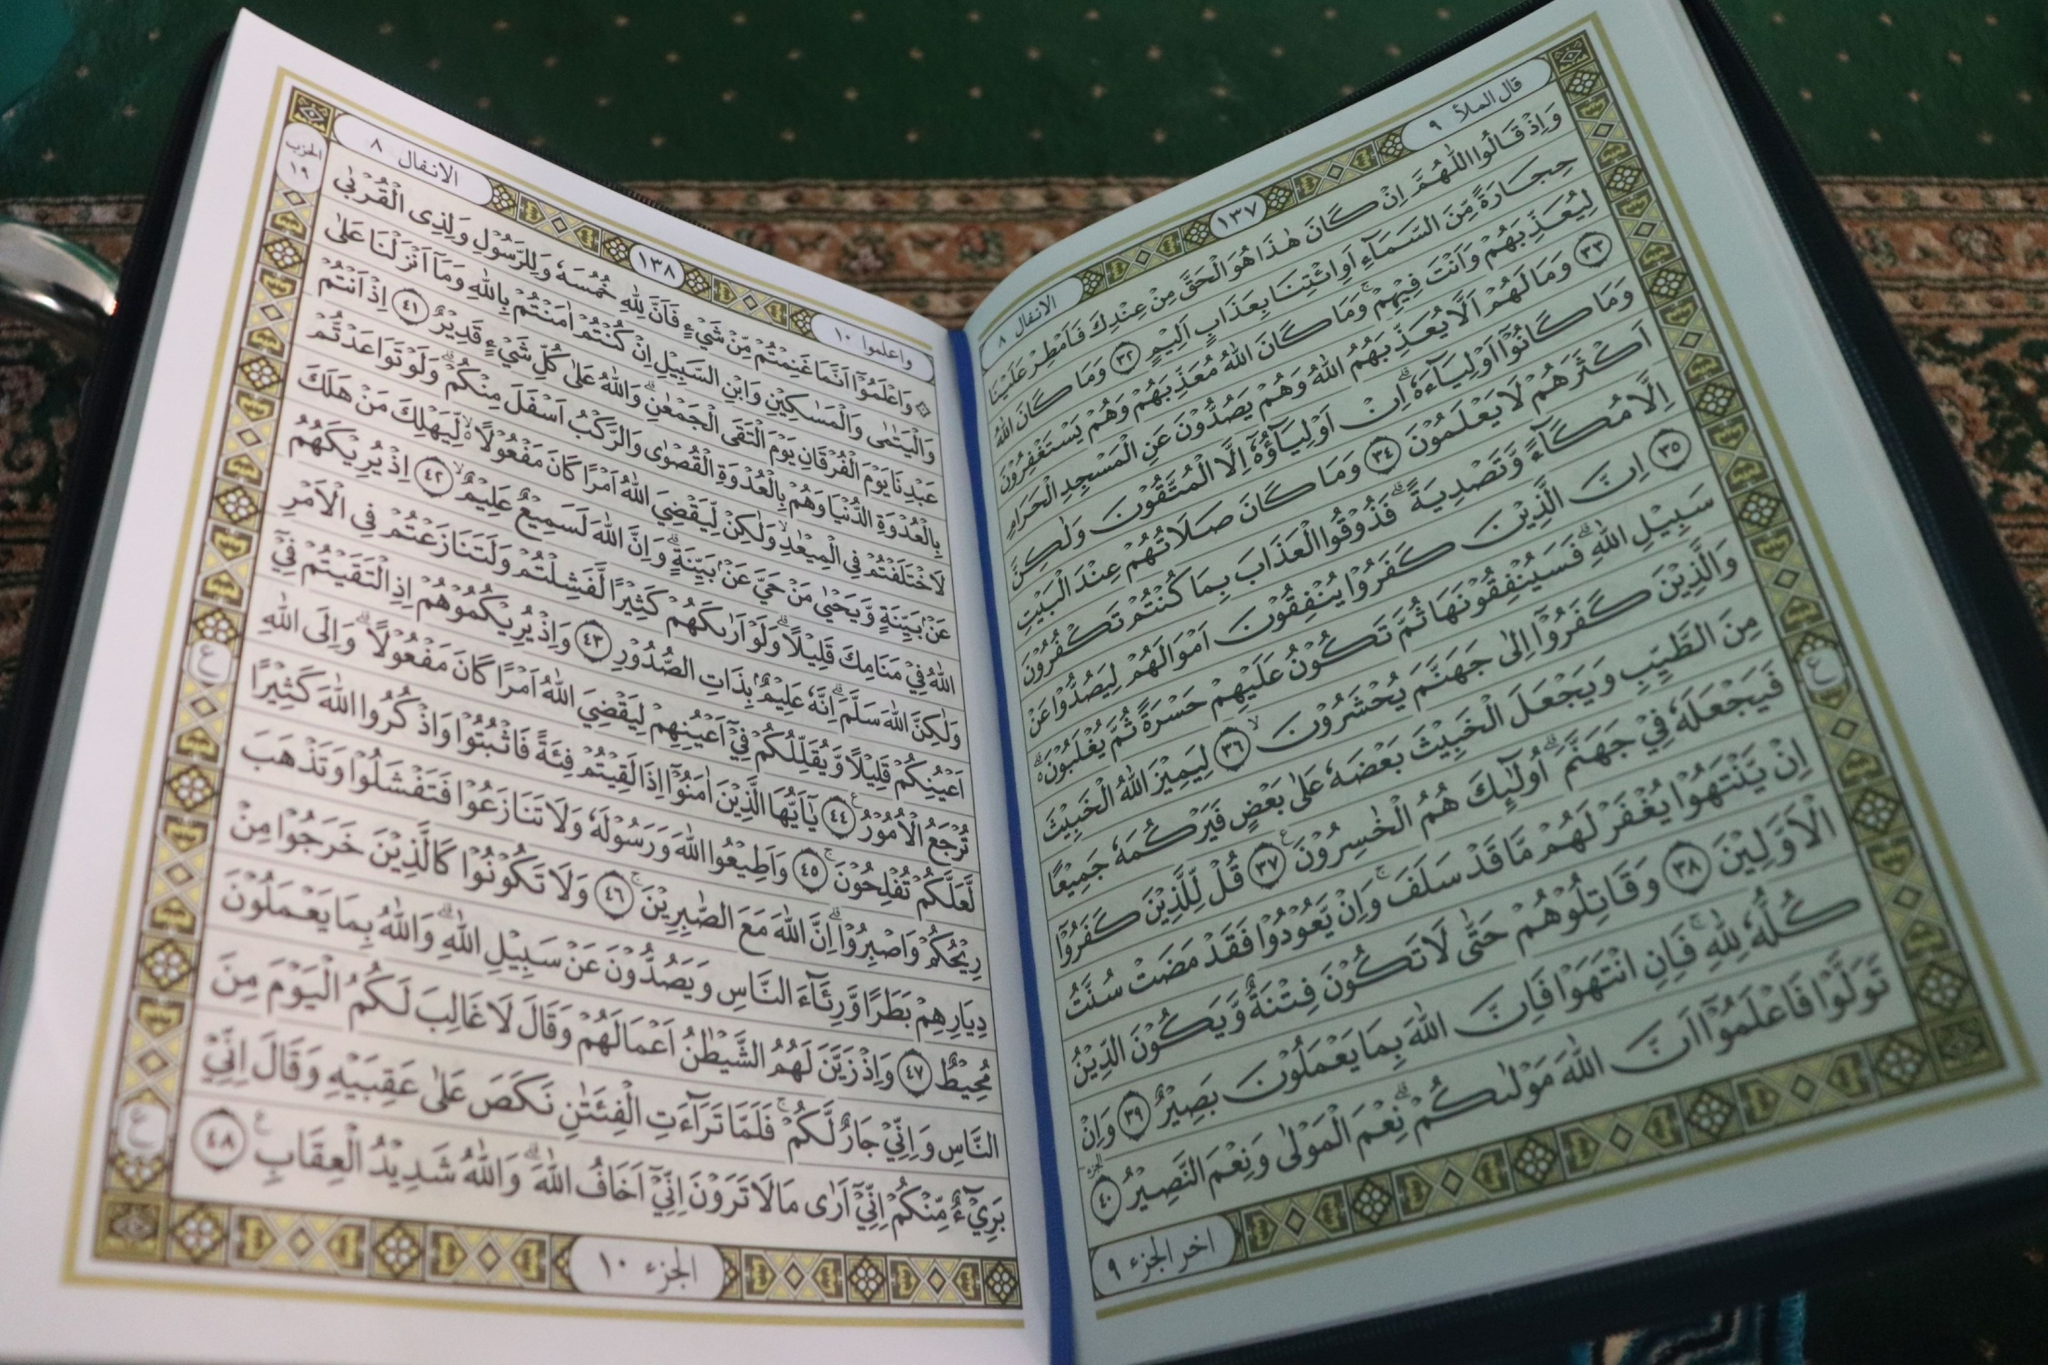Explain the visual content of the image in great detail. The image depicts an open book, specifically a religious text written in Arabic. The text is formatted in a traditional style with elegant calligraphy. The layout features densely packed lines of text, each separated by small decorative elements to indicate specific sections or verses. The margins of the pages are adorned with intricate geometric patterns and designs in gold and black, adding a decorative and reverent touch to the pages. The book appears to be carefully placed on a patterned textile, suggesting a setting of cultural or religious significance. 